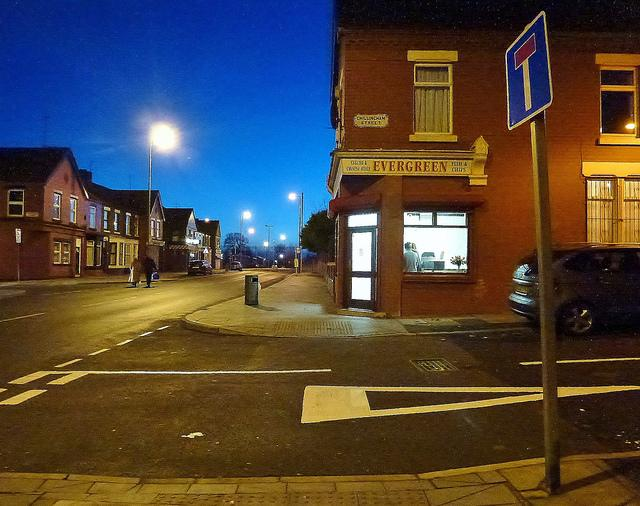What does the blue road sign warn of? Please explain your reasoning. intersection. The t on this blue traffic sign is the shape of the upcoming arrangement of road. 